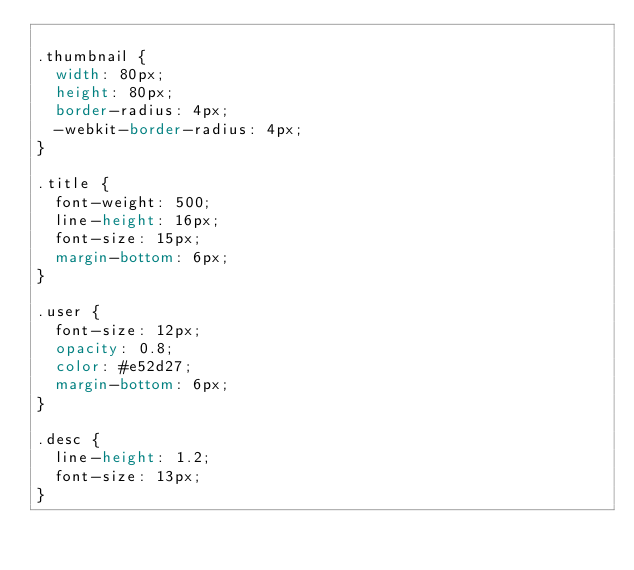Convert code to text. <code><loc_0><loc_0><loc_500><loc_500><_CSS_>
.thumbnail {
  width: 80px;
  height: 80px;
  border-radius: 4px;
  -webkit-border-radius: 4px;
}

.title {
  font-weight: 500;
  line-height: 16px;
  font-size: 15px;
  margin-bottom: 6px;
}

.user {
  font-size: 12px;
  opacity: 0.8;
  color: #e52d27;
  margin-bottom: 6px;
}

.desc {
  line-height: 1.2;
  font-size: 13px;
}
</code> 